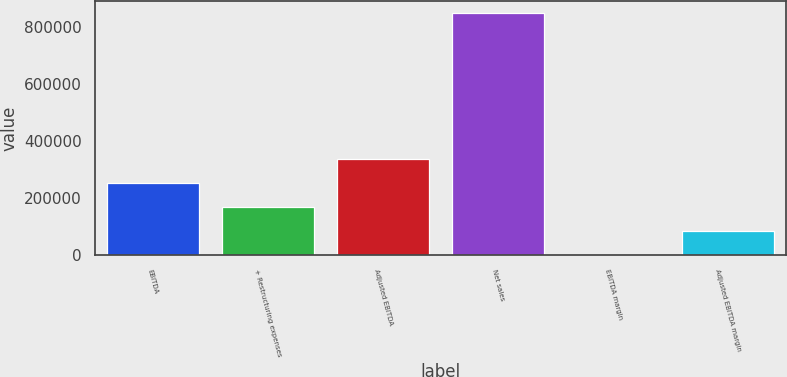Convert chart. <chart><loc_0><loc_0><loc_500><loc_500><bar_chart><fcel>EBITDA<fcel>+ Restructuring expenses<fcel>Adjusted EBITDA<fcel>Net sales<fcel>EBITDA margin<fcel>Adjusted EBITDA margin<nl><fcel>254750<fcel>169843<fcel>339658<fcel>849101<fcel>28.6<fcel>84935.8<nl></chart> 